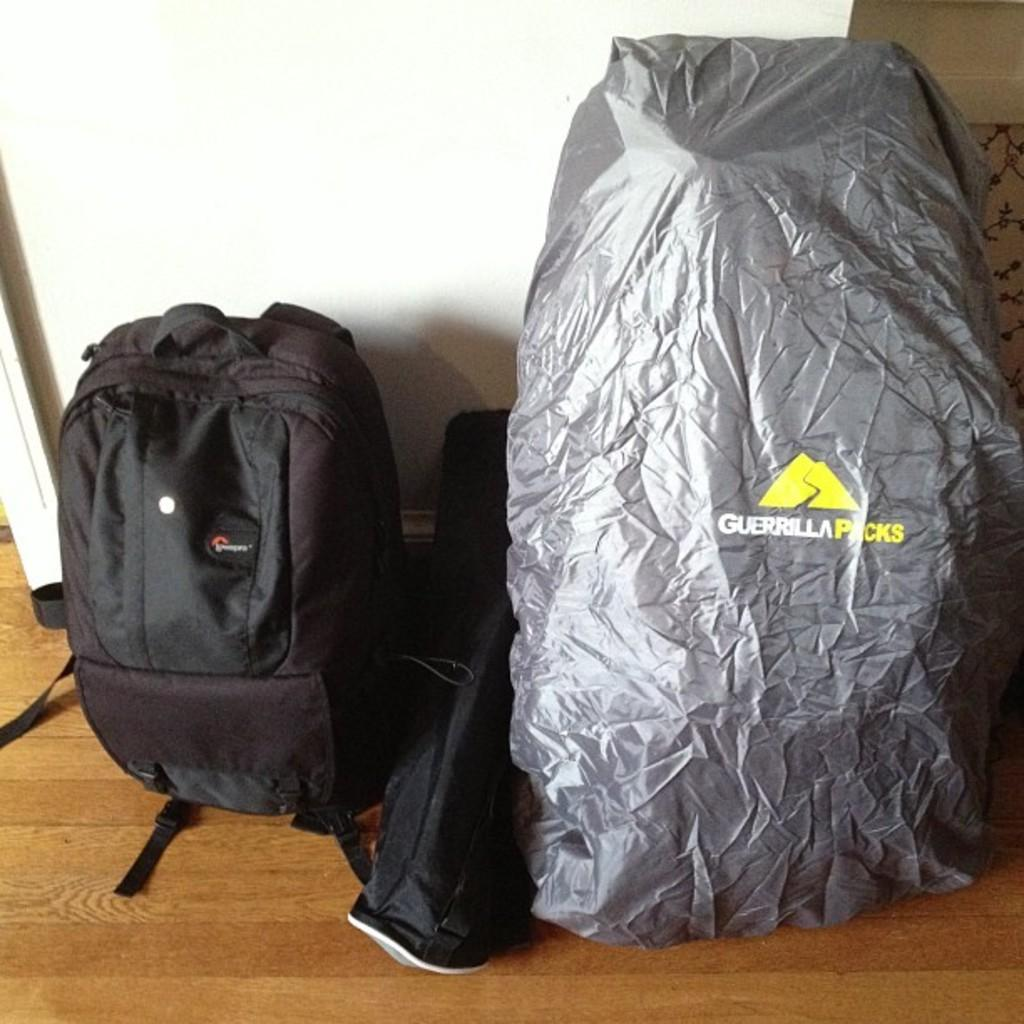<image>
Describe the image concisely. A blackpack next to a silver covering over something that says Guerrilla Packs on the outside. 